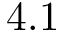<formula> <loc_0><loc_0><loc_500><loc_500>4 . 1</formula> 